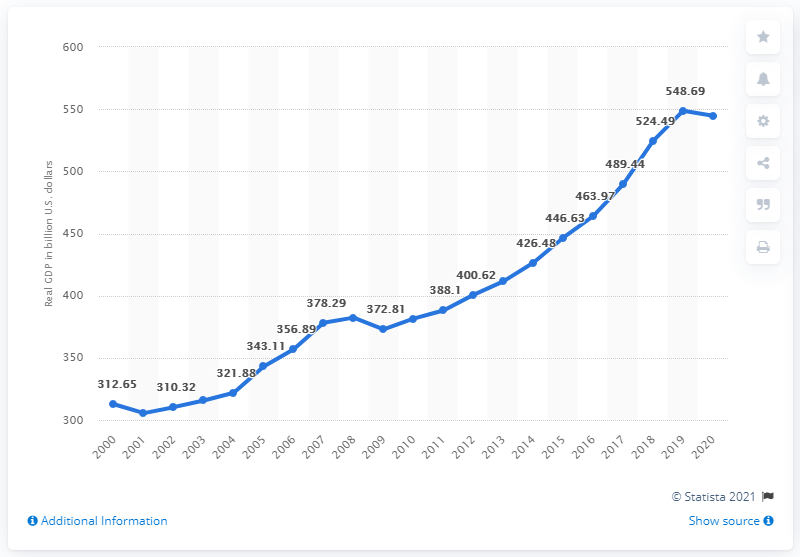Indicate a few pertinent items in this graphic. The previous year's GDP of Washington was $544.63. In 2020, the Gross Domestic Product (GDP) of Washington was 544.63. 